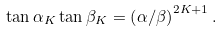Convert formula to latex. <formula><loc_0><loc_0><loc_500><loc_500>\tan \alpha _ { K } \tan \beta _ { K } = \left ( \alpha / \beta \right ) ^ { 2 K + 1 } .</formula> 